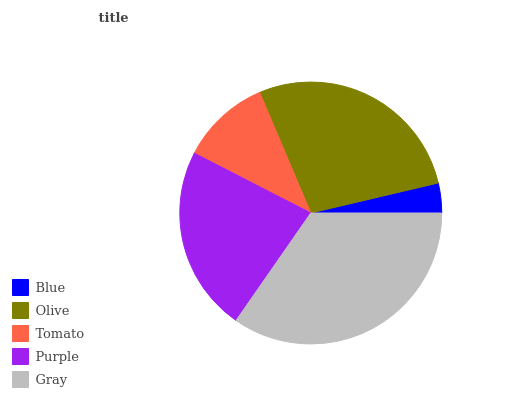Is Blue the minimum?
Answer yes or no. Yes. Is Gray the maximum?
Answer yes or no. Yes. Is Olive the minimum?
Answer yes or no. No. Is Olive the maximum?
Answer yes or no. No. Is Olive greater than Blue?
Answer yes or no. Yes. Is Blue less than Olive?
Answer yes or no. Yes. Is Blue greater than Olive?
Answer yes or no. No. Is Olive less than Blue?
Answer yes or no. No. Is Purple the high median?
Answer yes or no. Yes. Is Purple the low median?
Answer yes or no. Yes. Is Blue the high median?
Answer yes or no. No. Is Blue the low median?
Answer yes or no. No. 